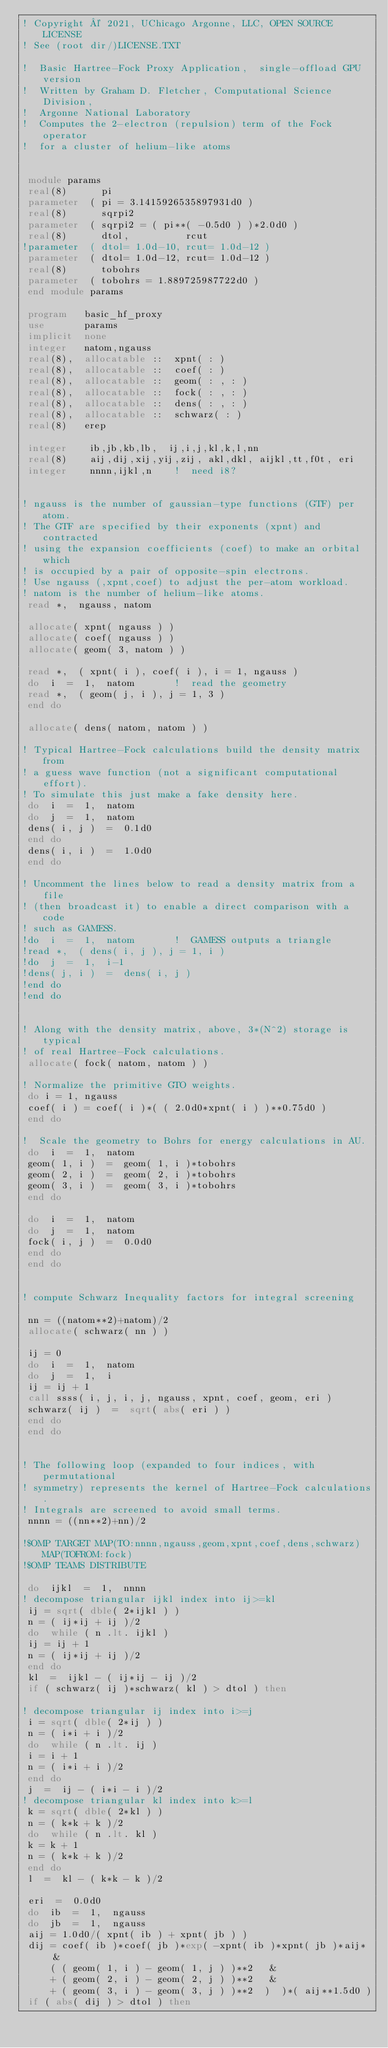Convert code to text. <code><loc_0><loc_0><loc_500><loc_500><_FORTRAN_>! Copyright © 2021, UChicago Argonne, LLC, OPEN SOURCE LICENSE
! See (root dir/)LICENSE.TXT 

!  Basic Hartree-Fock Proxy Application,  single-offload GPU version 
!  Written by Graham D. Fletcher, Computational Science Division, 
!  Argonne National Laboratory 
!  Computes the 2-electron (repulsion) term of the Fock operator  
!  for a cluster of helium-like atoms 


 module params  
 real(8)      pi  
 parameter  ( pi = 3.1415926535897931d0 )
 real(8)      sqrpi2
 parameter  ( sqrpi2 = ( pi**( -0.5d0 ) )*2.0d0 )
 real(8)      dtol,          rcut 
!parameter  ( dtol= 1.0d-10, rcut= 1.0d-12 ) 
 parameter  ( dtol= 1.0d-12, rcut= 1.0d-12 ) 
 real(8)      tobohrs 
 parameter  ( tobohrs = 1.889725987722d0 )
 end module params 

 program   basic_hf_proxy   
 use       params 
 implicit  none 
 integer   natom,ngauss 
 real(8),  allocatable ::  xpnt( : )
 real(8),  allocatable ::  coef( : )
 real(8),  allocatable ::  geom( : , : )
 real(8),  allocatable ::  fock( : , : )
 real(8),  allocatable ::  dens( : , : )
 real(8),  allocatable ::  schwarz( : )
 real(8)   erep

 integer    ib,jb,kb,lb,  ij,i,j,kl,k,l,nn 
 real(8)    aij,dij,xij,yij,zij, akl,dkl, aijkl,tt,f0t, eri 
 integer    nnnn,ijkl,n    !  need i8?


! ngauss is the number of gaussian-type functions (GTF) per atom.
! The GTF are specified by their exponents (xpnt) and contracted 
! using the expansion coefficients (coef) to make an orbital which 
! is occupied by a pair of opposite-spin electrons.
! Use ngauss (,xpnt,coef) to adjust the per-atom workload.
! natom is the number of helium-like atoms.
 read *,  ngauss, natom 

 allocate( xpnt( ngauss ) )  
 allocate( coef( ngauss ) )  
 allocate( geom( 3, natom ) )  

 read *,  ( xpnt( i ), coef( i ), i = 1, ngauss ) 
 do  i  =  1,  natom       !  read the geometry 
 read *,  ( geom( j, i ), j = 1, 3 )  
 end do

 allocate( dens( natom, natom ) )  

! Typical Hartree-Fock calculations build the density matrix from 
! a guess wave function (not a significant computational effort). 
! To simulate this just make a fake density here.
 do  i  =  1,  natom  
 do  j  =  1,  natom  
 dens( i, j )  =  0.1d0   
 end do
 dens( i, i )  =  1.0d0   
 end do

! Uncomment the lines below to read a density matrix from a file 
! (then broadcast it) to enable a direct comparison with a code 
! such as GAMESS. 
!do  i  =  1,  natom       !  GAMESS outputs a triangle 
!read *,  ( dens( i, j ), j = 1, i )  
!do  j  =  1,  i-1  
!dens( j, i )  =  dens( i, j )  
!end do
!end do

 
! Along with the density matrix, above, 3*(N^2) storage is typical 
! of real Hartree-Fock calculations. 
 allocate( fock( natom, natom ) )  

! Normalize the primitive GTO weights.
 do i = 1, ngauss 
 coef( i ) = coef( i )*( ( 2.0d0*xpnt( i ) )**0.75d0 )
 end do

!  Scale the geometry to Bohrs for energy calculations in AU.
 do  i  =  1,  natom 
 geom( 1, i )  =  geom( 1, i )*tobohrs   
 geom( 2, i )  =  geom( 2, i )*tobohrs   
 geom( 3, i )  =  geom( 3, i )*tobohrs   
 end do

 do  i  =  1,  natom  
 do  j  =  1,  natom  
 fock( i, j )  =  0.0d0  
 end do
 end do


! compute Schwarz Inequality factors for integral screening 

 nn = ((natom**2)+natom)/2  
 allocate( schwarz( nn ) )  

 ij = 0 
 do  i  =  1,  natom  
 do  j  =  1,  i  
 ij = ij + 1 
 call ssss( i, j, i, j, ngauss, xpnt, coef, geom, eri )
 schwarz( ij )  =  sqrt( abs( eri ) )  
 end do
 end do


! The following loop (expanded to four indices, with permutational
! symmetry) represents the kernel of Hartree-Fock calculations.
! Integrals are screened to avoid small terms.
 nnnn = ((nn**2)+nn)/2

!$OMP TARGET MAP(TO:nnnn,ngauss,geom,xpnt,coef,dens,schwarz) MAP(TOFROM:fock)
!$OMP TEAMS DISTRIBUTE 

 do  ijkl  =  1,  nnnn
! decompose triangular ijkl index into ij>=kl
 ij = sqrt( dble( 2*ijkl ) )
 n = ( ij*ij + ij )/2
 do  while ( n .lt. ijkl )
 ij = ij + 1
 n = ( ij*ij + ij )/2
 end do
 kl  =  ijkl - ( ij*ij - ij )/2
 if ( schwarz( ij )*schwarz( kl ) > dtol ) then      

! decompose triangular ij index into i>=j
 i = sqrt( dble( 2*ij ) )
 n = ( i*i + i )/2
 do  while ( n .lt. ij )
 i = i + 1
 n = ( i*i + i )/2
 end do
 j  =  ij - ( i*i - i )/2
! decompose triangular kl index into k>=l
 k = sqrt( dble( 2*kl ) )
 n = ( k*k + k )/2
 do  while ( n .lt. kl )
 k = k + 1
 n = ( k*k + k )/2
 end do
 l  =  kl - ( k*k - k )/2

 eri  =  0.0d0
 do  ib  =  1,  ngauss
 do  jb  =  1,  ngauss
 aij = 1.0d0/( xpnt( ib ) + xpnt( jb ) )
 dij = coef( ib )*coef( jb )*exp( -xpnt( ib )*xpnt( jb )*aij*  &
     ( ( geom( 1, i ) - geom( 1, j ) )**2   &
     + ( geom( 2, i ) - geom( 2, j ) )**2   &
     + ( geom( 3, i ) - geom( 3, j ) )**2  )  )*( aij**1.5d0 )
 if ( abs( dij ) > dtol ) then</code> 